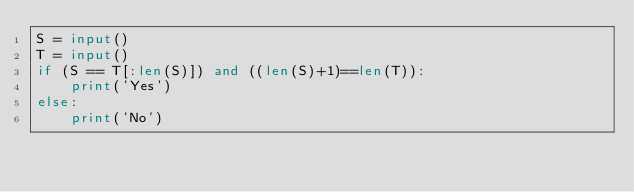Convert code to text. <code><loc_0><loc_0><loc_500><loc_500><_Python_>S = input()
T = input()
if (S == T[:len(S)]) and ((len(S)+1)==len(T)):
    print('Yes')
else:
    print('No')</code> 